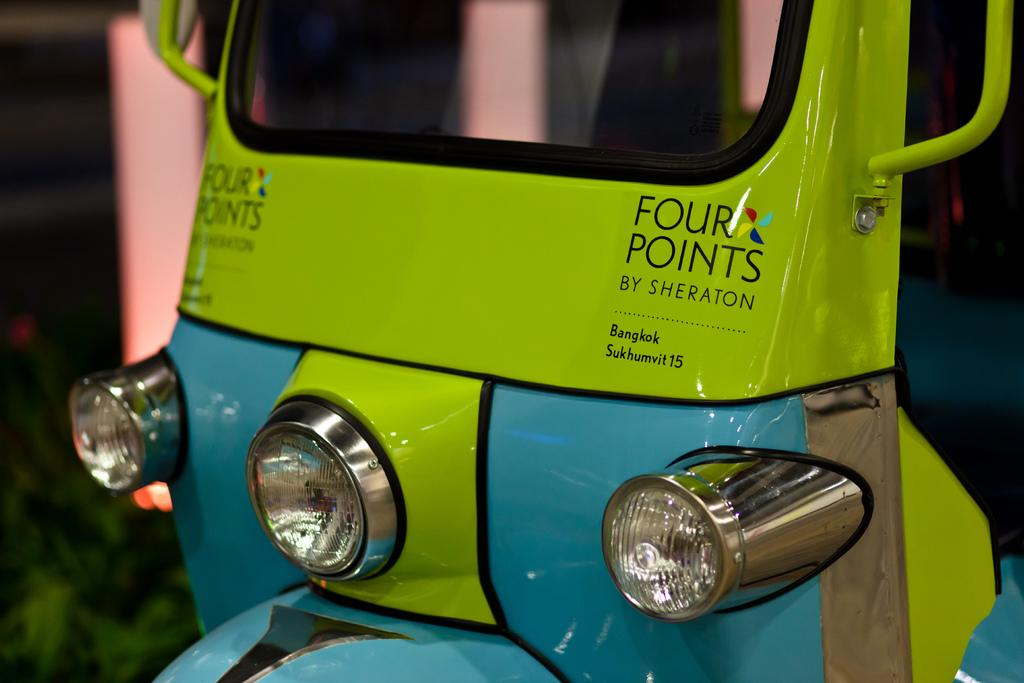What vehicle is in the foreground of the image? There is an auto rickshaw in the foreground of the image. Can you describe the time of day when the image was taken? The image is likely taken during nighttime. Where might this image have been taken? The image may have been taken on a road. What type of cabbage is being used as a mark on the pail in the image? There is no cabbage or pail present in the image. 